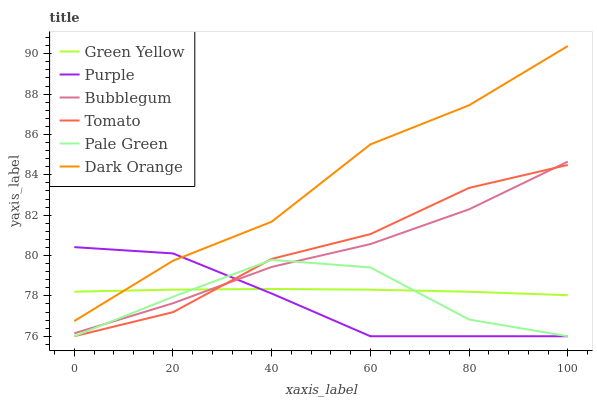Does Purple have the minimum area under the curve?
Answer yes or no. Yes. Does Dark Orange have the maximum area under the curve?
Answer yes or no. Yes. Does Dark Orange have the minimum area under the curve?
Answer yes or no. No. Does Purple have the maximum area under the curve?
Answer yes or no. No. Is Green Yellow the smoothest?
Answer yes or no. Yes. Is Pale Green the roughest?
Answer yes or no. Yes. Is Dark Orange the smoothest?
Answer yes or no. No. Is Dark Orange the roughest?
Answer yes or no. No. Does Tomato have the lowest value?
Answer yes or no. Yes. Does Dark Orange have the lowest value?
Answer yes or no. No. Does Dark Orange have the highest value?
Answer yes or no. Yes. Does Purple have the highest value?
Answer yes or no. No. Is Pale Green less than Dark Orange?
Answer yes or no. Yes. Is Dark Orange greater than Bubblegum?
Answer yes or no. Yes. Does Purple intersect Bubblegum?
Answer yes or no. Yes. Is Purple less than Bubblegum?
Answer yes or no. No. Is Purple greater than Bubblegum?
Answer yes or no. No. Does Pale Green intersect Dark Orange?
Answer yes or no. No. 